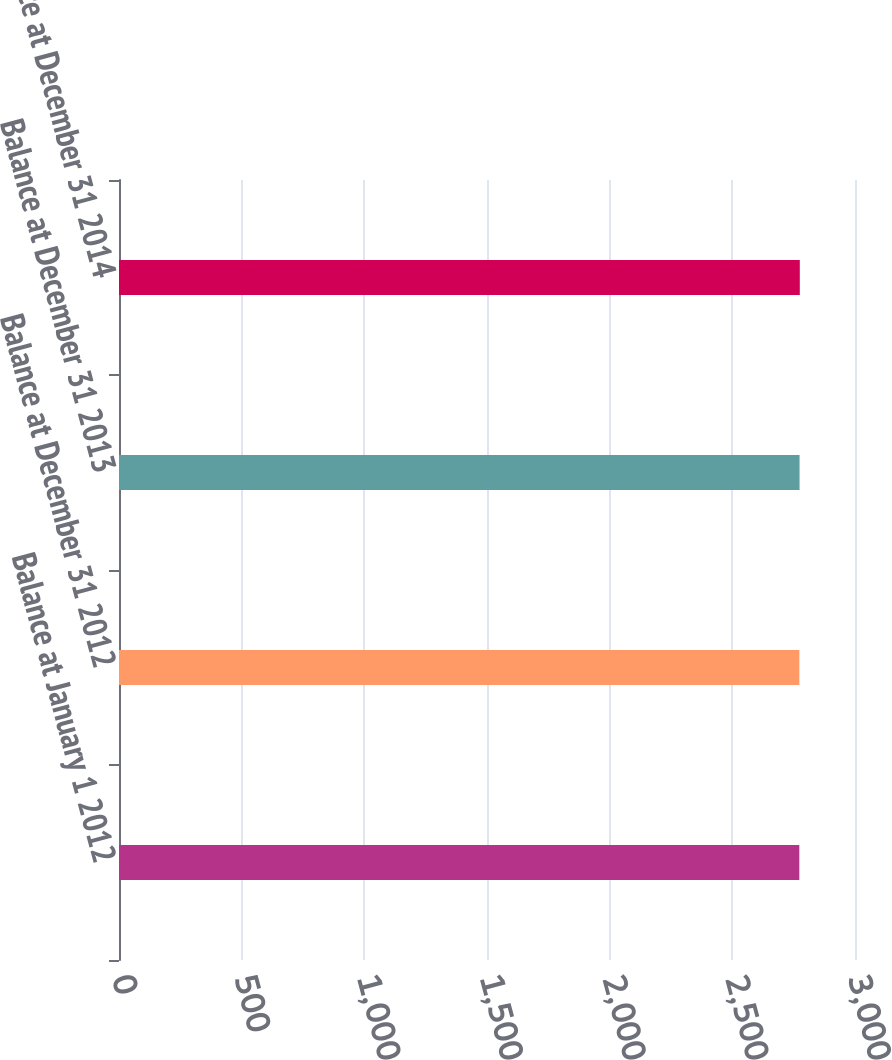Convert chart to OTSL. <chart><loc_0><loc_0><loc_500><loc_500><bar_chart><fcel>Balance at January 1 2012<fcel>Balance at December 31 2012<fcel>Balance at December 31 2013<fcel>Balance at December 31 2014<nl><fcel>2773<fcel>2773.2<fcel>2774<fcel>2775<nl></chart> 